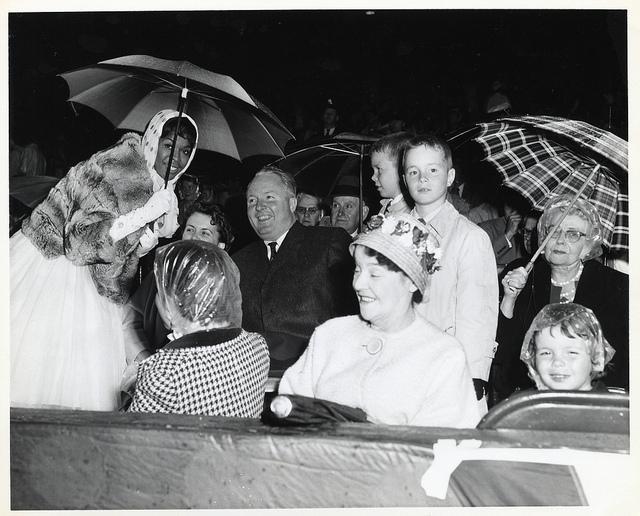How many people are in the picture?
Give a very brief answer. 9. How many umbrellas are there?
Give a very brief answer. 4. 